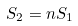<formula> <loc_0><loc_0><loc_500><loc_500>S _ { 2 } = n S _ { 1 }</formula> 